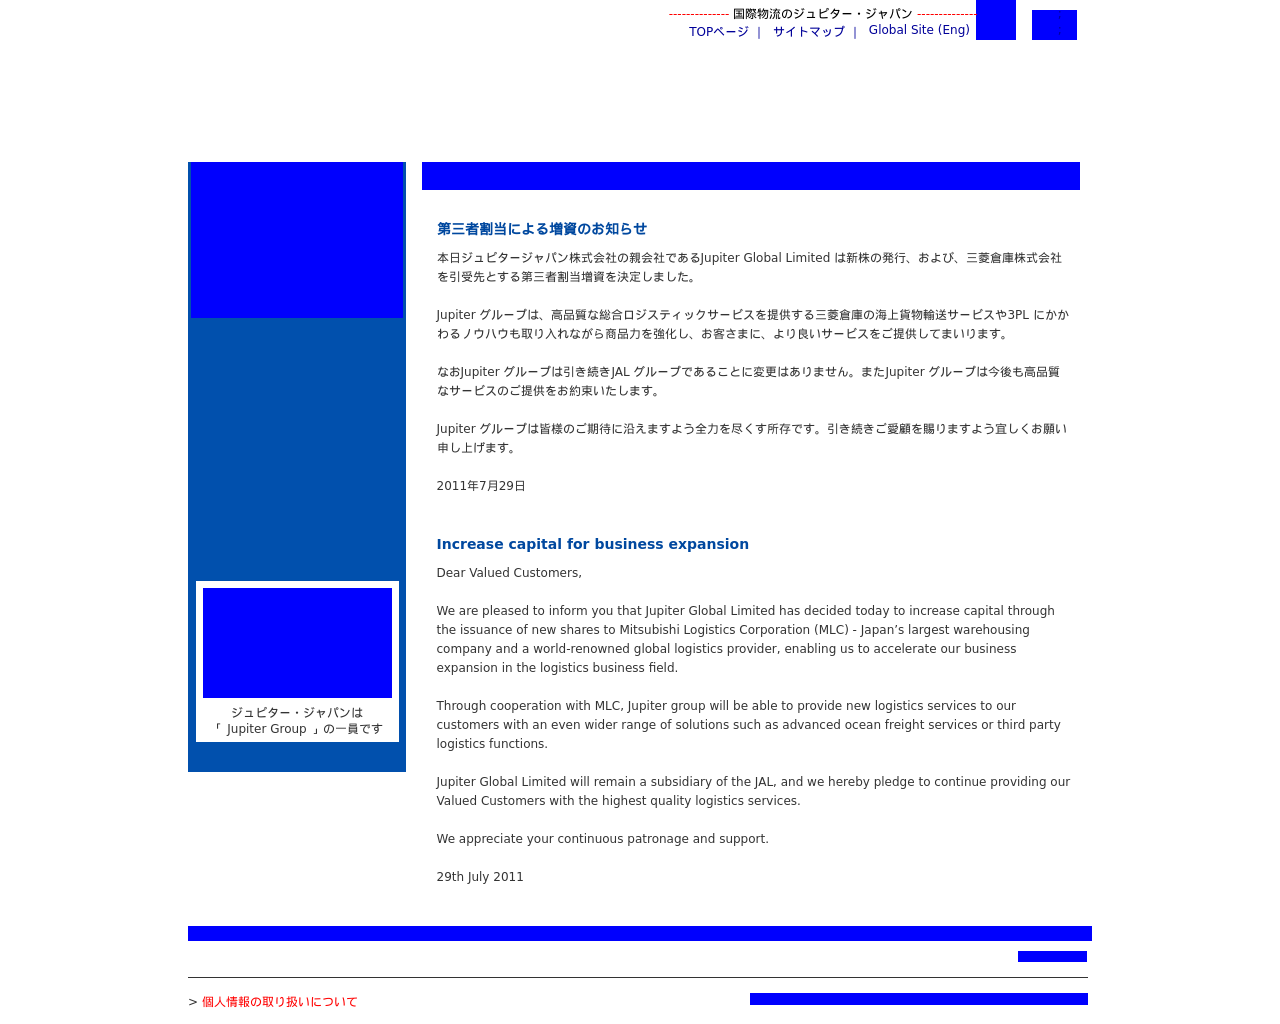Can you describe the corporate updates shown in the website image? The image shows content related to a corporate announcement regarding Jupiter Global Limited's increase in capital by issuing new shares. The bulletin mentions cooperation with Mitsubishi Logistics Corporation, enhancing logistics services, and a commitment to continued high-quality service. This financial move seems aimed at expanding operations and strengthening their logistics capabilities. 